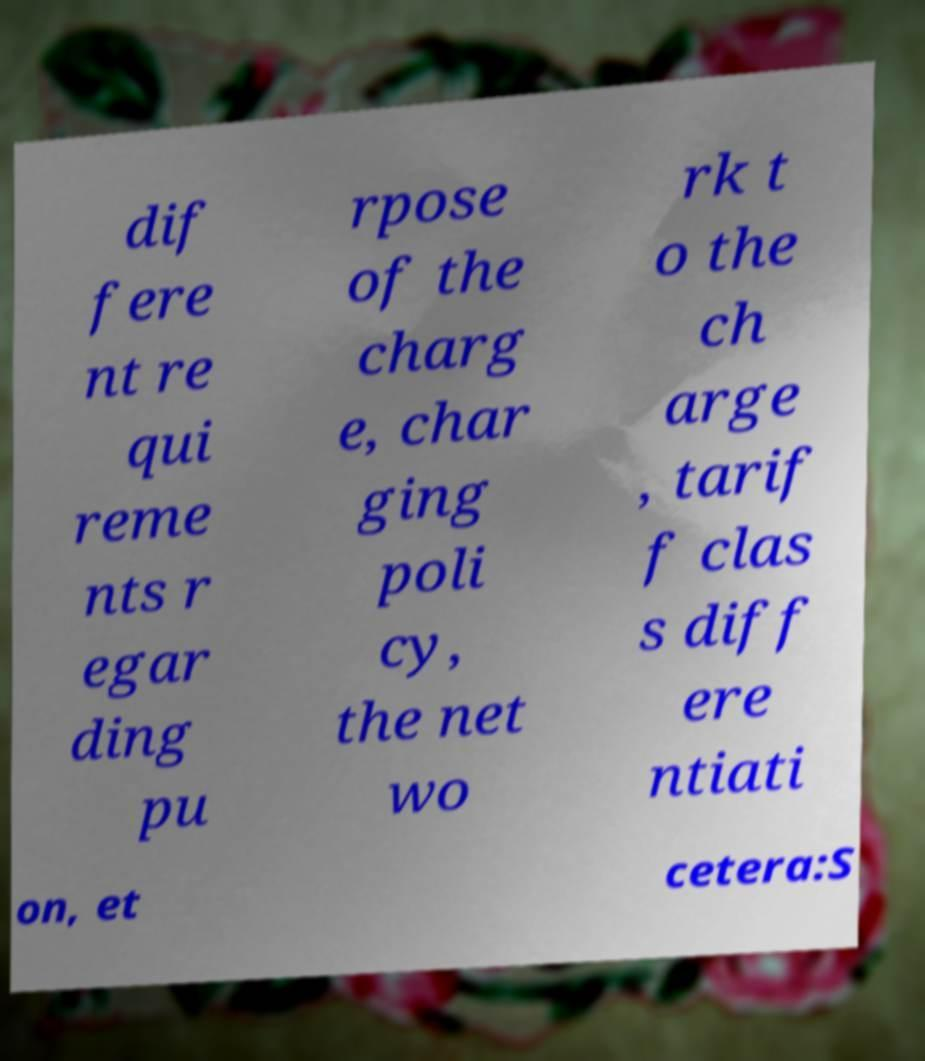Please read and relay the text visible in this image. What does it say? dif fere nt re qui reme nts r egar ding pu rpose of the charg e, char ging poli cy, the net wo rk t o the ch arge , tarif f clas s diff ere ntiati on, et cetera:S 